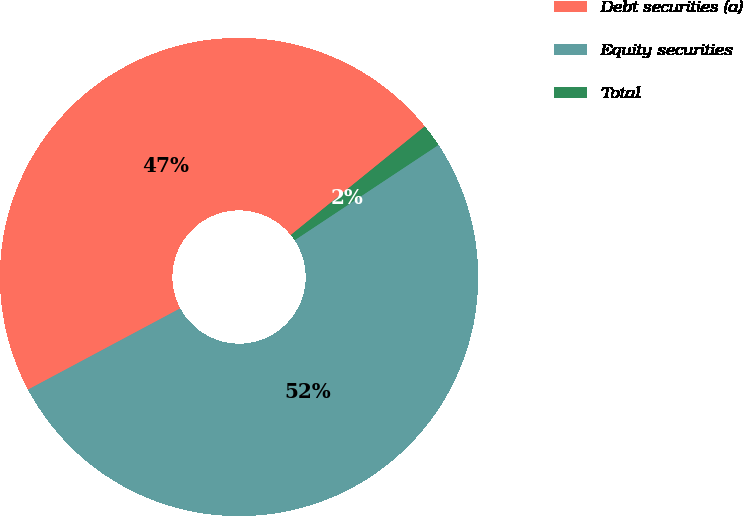<chart> <loc_0><loc_0><loc_500><loc_500><pie_chart><fcel>Debt securities (a)<fcel>Equity securities<fcel>Total<nl><fcel>46.96%<fcel>51.51%<fcel>1.53%<nl></chart> 